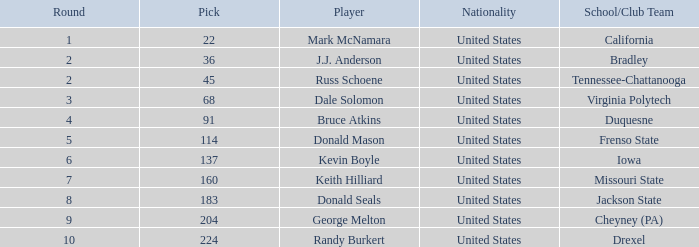Write the full table. {'header': ['Round', 'Pick', 'Player', 'Nationality', 'School/Club Team'], 'rows': [['1', '22', 'Mark McNamara', 'United States', 'California'], ['2', '36', 'J.J. Anderson', 'United States', 'Bradley'], ['2', '45', 'Russ Schoene', 'United States', 'Tennessee-Chattanooga'], ['3', '68', 'Dale Solomon', 'United States', 'Virginia Polytech'], ['4', '91', 'Bruce Atkins', 'United States', 'Duquesne'], ['5', '114', 'Donald Mason', 'United States', 'Frenso State'], ['6', '137', 'Kevin Boyle', 'United States', 'Iowa'], ['7', '160', 'Keith Hilliard', 'United States', 'Missouri State'], ['8', '183', 'Donald Seals', 'United States', 'Jackson State'], ['9', '204', 'George Melton', 'United States', 'Cheyney (PA)'], ['10', '224', 'Randy Burkert', 'United States', 'Drexel']]} What is the earliest round that Donald Mason had a pick larger than 114? None. 